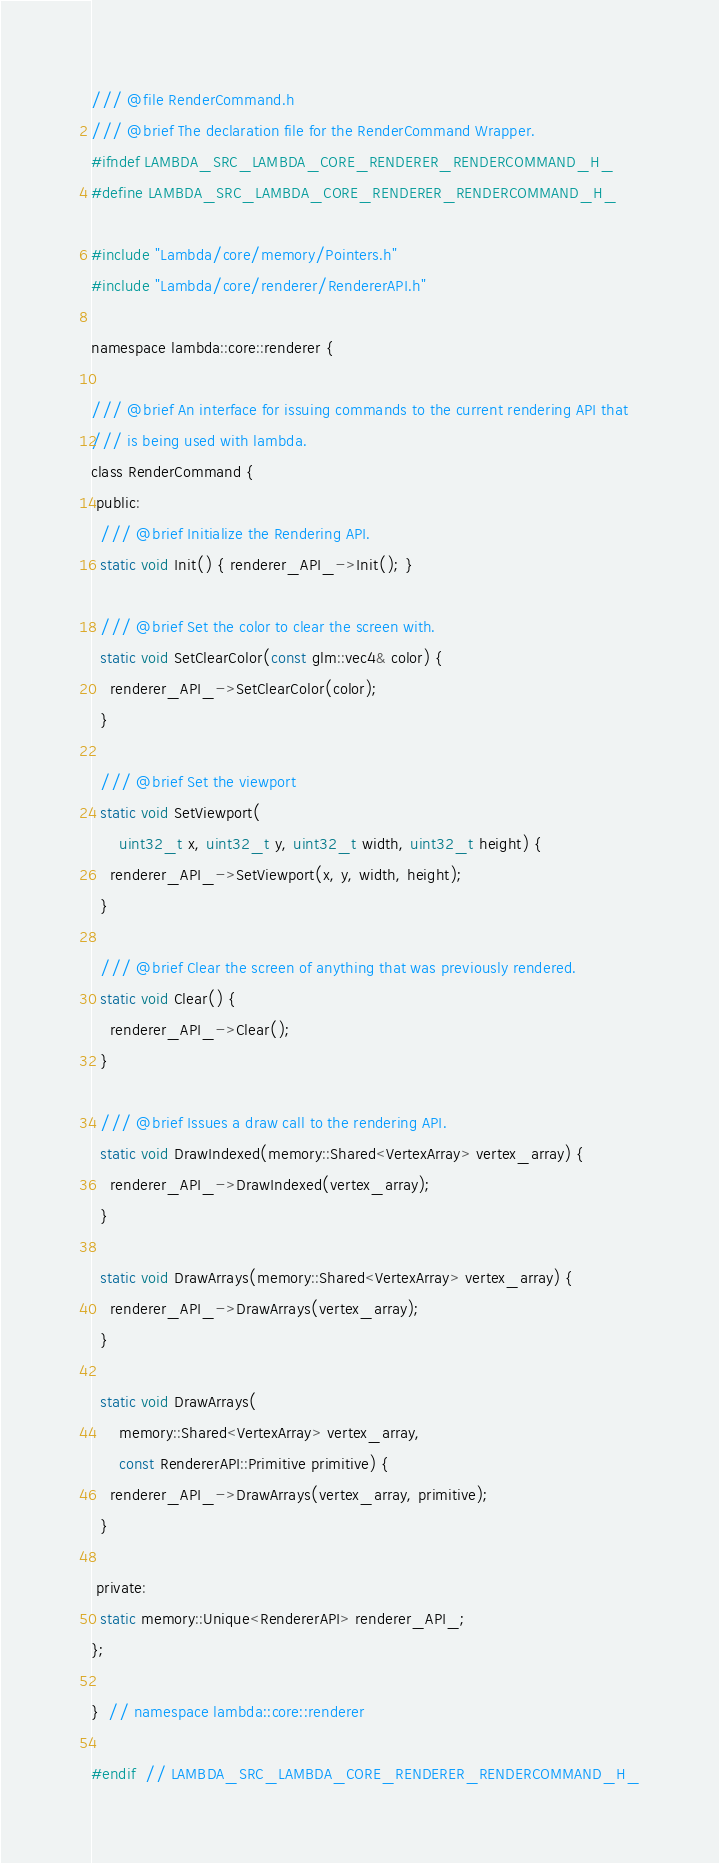Convert code to text. <code><loc_0><loc_0><loc_500><loc_500><_C_>/// @file RenderCommand.h
/// @brief The declaration file for the RenderCommand Wrapper.
#ifndef LAMBDA_SRC_LAMBDA_CORE_RENDERER_RENDERCOMMAND_H_
#define LAMBDA_SRC_LAMBDA_CORE_RENDERER_RENDERCOMMAND_H_

#include "Lambda/core/memory/Pointers.h"
#include "Lambda/core/renderer/RendererAPI.h"

namespace lambda::core::renderer {

/// @brief An interface for issuing commands to the current rendering API that
/// is being used with lambda.
class RenderCommand {
 public:
  /// @brief Initialize the Rendering API.
  static void Init() { renderer_API_->Init(); }

  /// @brief Set the color to clear the screen with.
  static void SetClearColor(const glm::vec4& color) {
    renderer_API_->SetClearColor(color);
  }

  /// @brief Set the viewport
  static void SetViewport(
      uint32_t x, uint32_t y, uint32_t width, uint32_t height) {
    renderer_API_->SetViewport(x, y, width, height);
  }

  /// @brief Clear the screen of anything that was previously rendered.
  static void Clear() {
    renderer_API_->Clear();
  }

  /// @brief Issues a draw call to the rendering API.
  static void DrawIndexed(memory::Shared<VertexArray> vertex_array) {
    renderer_API_->DrawIndexed(vertex_array);
  }

  static void DrawArrays(memory::Shared<VertexArray> vertex_array) {
    renderer_API_->DrawArrays(vertex_array);
  }

  static void DrawArrays(
      memory::Shared<VertexArray> vertex_array,
      const RendererAPI::Primitive primitive) {
    renderer_API_->DrawArrays(vertex_array, primitive);
  }

 private:
  static memory::Unique<RendererAPI> renderer_API_;
};

}  // namespace lambda::core::renderer

#endif  // LAMBDA_SRC_LAMBDA_CORE_RENDERER_RENDERCOMMAND_H_
</code> 